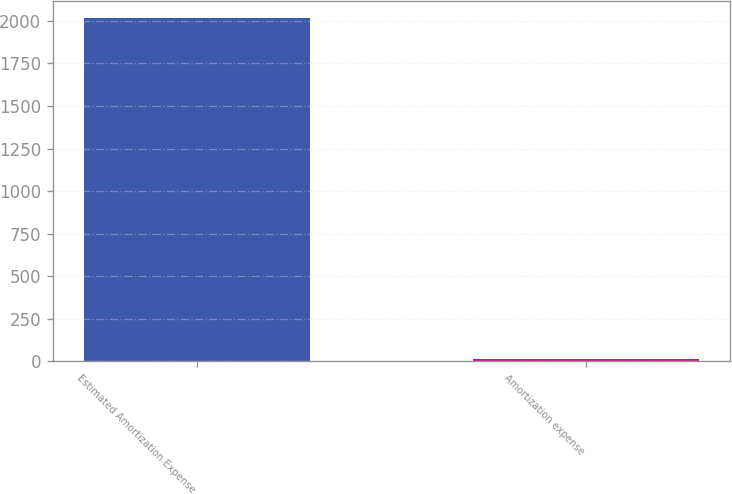<chart> <loc_0><loc_0><loc_500><loc_500><bar_chart><fcel>Estimated Amortization Expense<fcel>Amortization expense<nl><fcel>2016<fcel>15<nl></chart> 